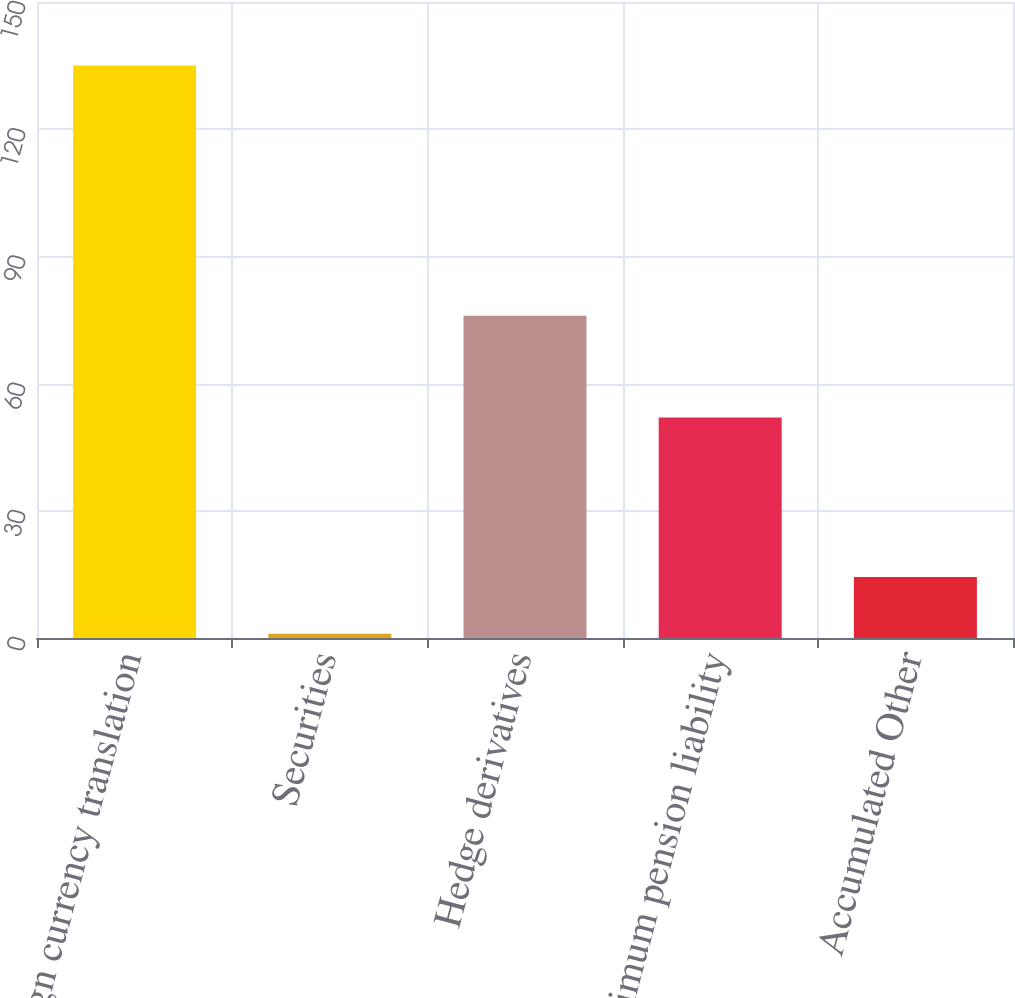<chart> <loc_0><loc_0><loc_500><loc_500><bar_chart><fcel>Foreign currency translation<fcel>Securities<fcel>Hedge derivatives<fcel>Minimum pension liability<fcel>Accumulated Other<nl><fcel>135<fcel>1<fcel>76<fcel>52<fcel>14.4<nl></chart> 